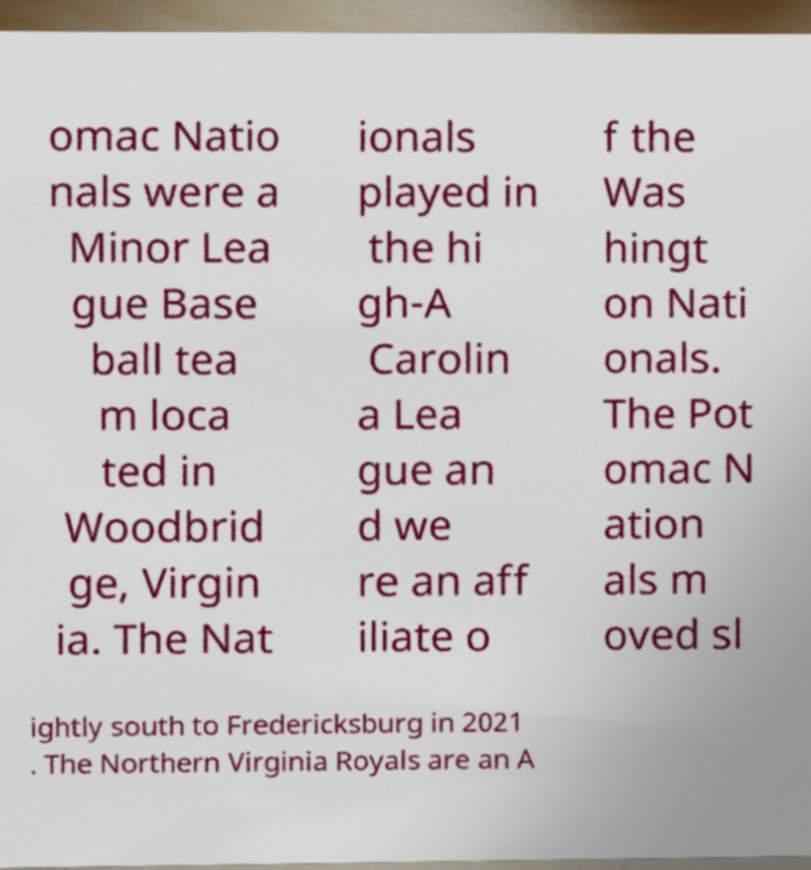Please read and relay the text visible in this image. What does it say? omac Natio nals were a Minor Lea gue Base ball tea m loca ted in Woodbrid ge, Virgin ia. The Nat ionals played in the hi gh-A Carolin a Lea gue an d we re an aff iliate o f the Was hingt on Nati onals. The Pot omac N ation als m oved sl ightly south to Fredericksburg in 2021 . The Northern Virginia Royals are an A 